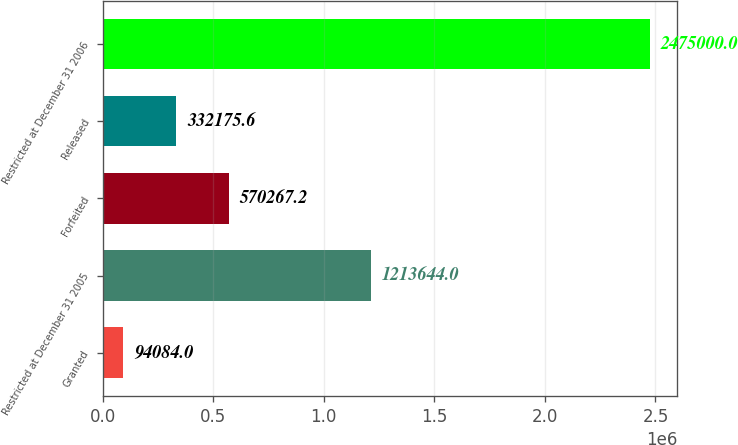Convert chart to OTSL. <chart><loc_0><loc_0><loc_500><loc_500><bar_chart><fcel>Granted<fcel>Restricted at December 31 2005<fcel>Forfeited<fcel>Released<fcel>Restricted at December 31 2006<nl><fcel>94084<fcel>1.21364e+06<fcel>570267<fcel>332176<fcel>2.475e+06<nl></chart> 